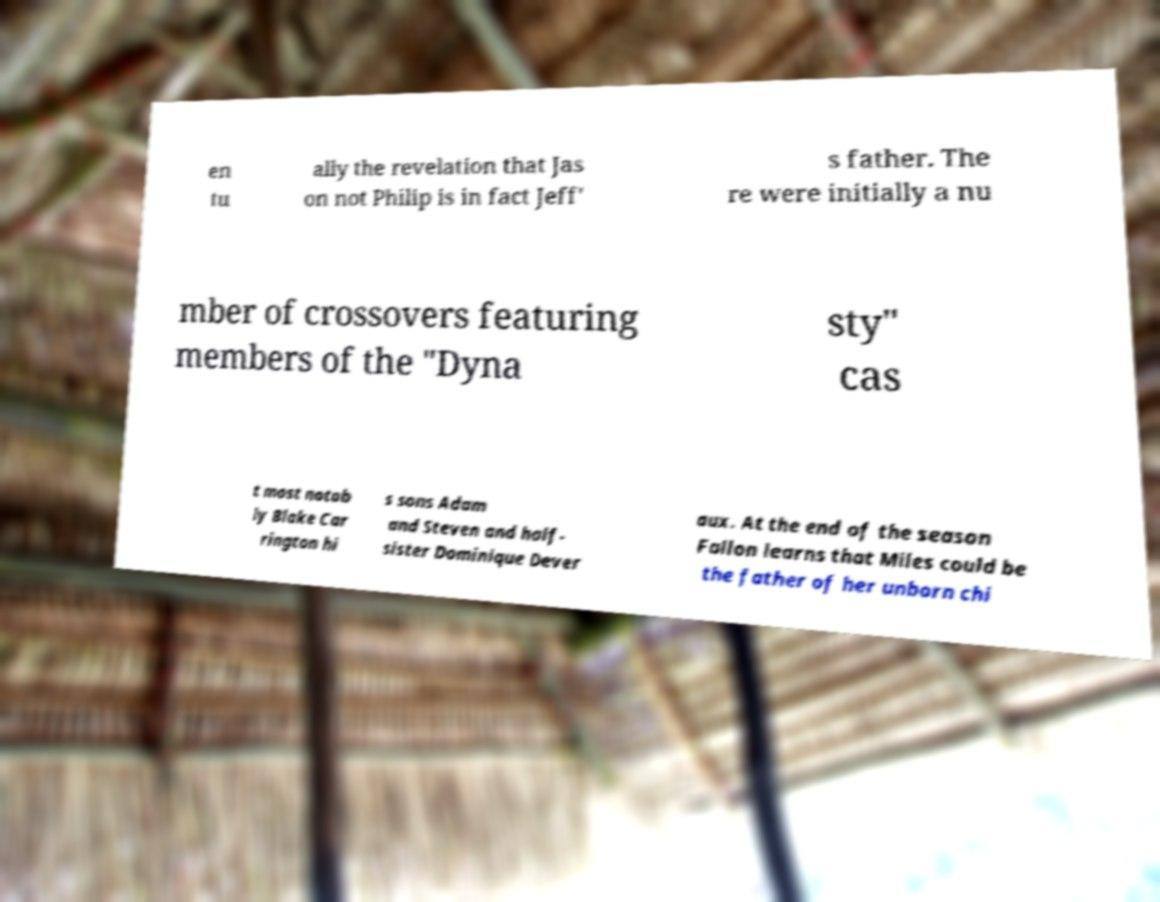For documentation purposes, I need the text within this image transcribed. Could you provide that? en tu ally the revelation that Jas on not Philip is in fact Jeff' s father. The re were initially a nu mber of crossovers featuring members of the "Dyna sty" cas t most notab ly Blake Car rington hi s sons Adam and Steven and half- sister Dominique Dever aux. At the end of the season Fallon learns that Miles could be the father of her unborn chi 